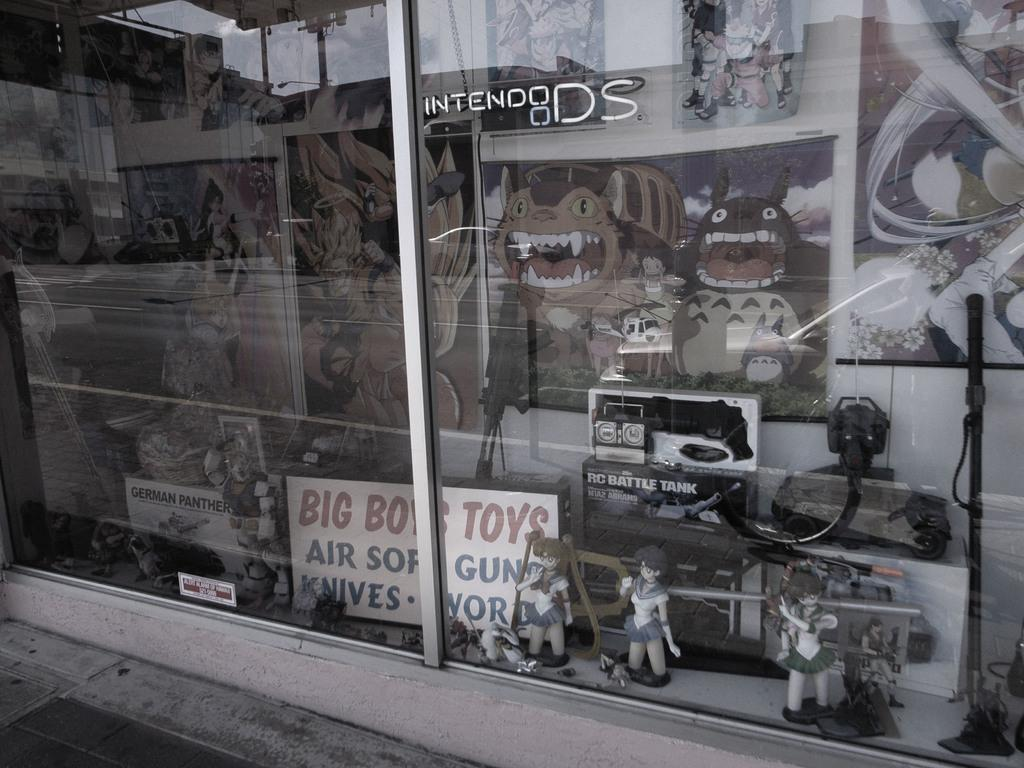What type of structure is shown in the image? The image is of a building. What other objects can be seen inside the building? There are toys and posters on the wall visible in the image. What is used for reflecting light and images in the image? There is a mirror in the image. What can be seen in the mirror's reflection? The sky is reflected in the mirror. What type of stem can be seen growing from the toys in the image? There are no plants or stems visible in the image; it features toys and other objects inside a building. 